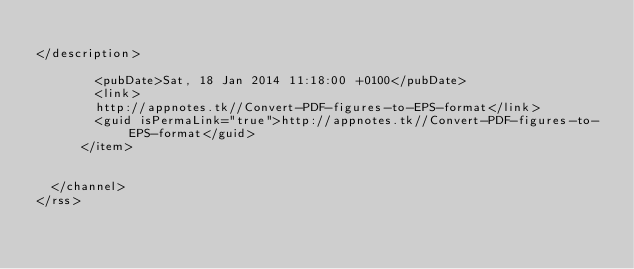<code> <loc_0><loc_0><loc_500><loc_500><_XML_>
</description>
        
        <pubDate>Sat, 18 Jan 2014 11:18:00 +0100</pubDate>
        <link>
        http://appnotes.tk//Convert-PDF-figures-to-EPS-format</link>
        <guid isPermaLink="true">http://appnotes.tk//Convert-PDF-figures-to-EPS-format</guid>
      </item>
      
    
  </channel>
</rss>
</code> 